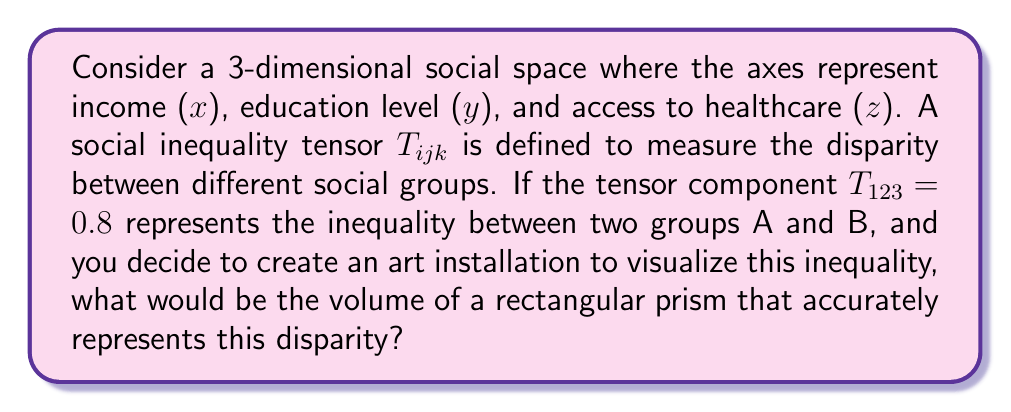Solve this math problem. To solve this problem, we'll follow these steps:

1) In tensor notation, $T_{123}$ represents the component of the tensor in the $x$, $y$, and $z$ directions respectively.

2) The value 0.8 indicates a high level of inequality, as tensor components are typically normalized between 0 and 1.

3) To represent this visually, we can create a rectangular prism where each dimension corresponds to one of the social factors (income, education, healthcare).

4) The volume of this prism will represent the magnitude of inequality.

5) Since the tensor component is 0.8, we can use this as the length of each side of our prism.

6) The volume of a rectangular prism is given by the formula:

   $$V = l \times w \times h$$

   where $l$, $w$, and $h$ are the length, width, and height respectively.

7) Substituting 0.8 for each dimension:

   $$V = 0.8 \times 0.8 \times 0.8 = 0.512$$

8) Therefore, the volume of the rectangular prism representing this inequality is 0.512 cubic units.

This volume provides a visual representation of the inequality, where a larger volume indicates greater disparity between groups.
Answer: $0.512$ cubic units 